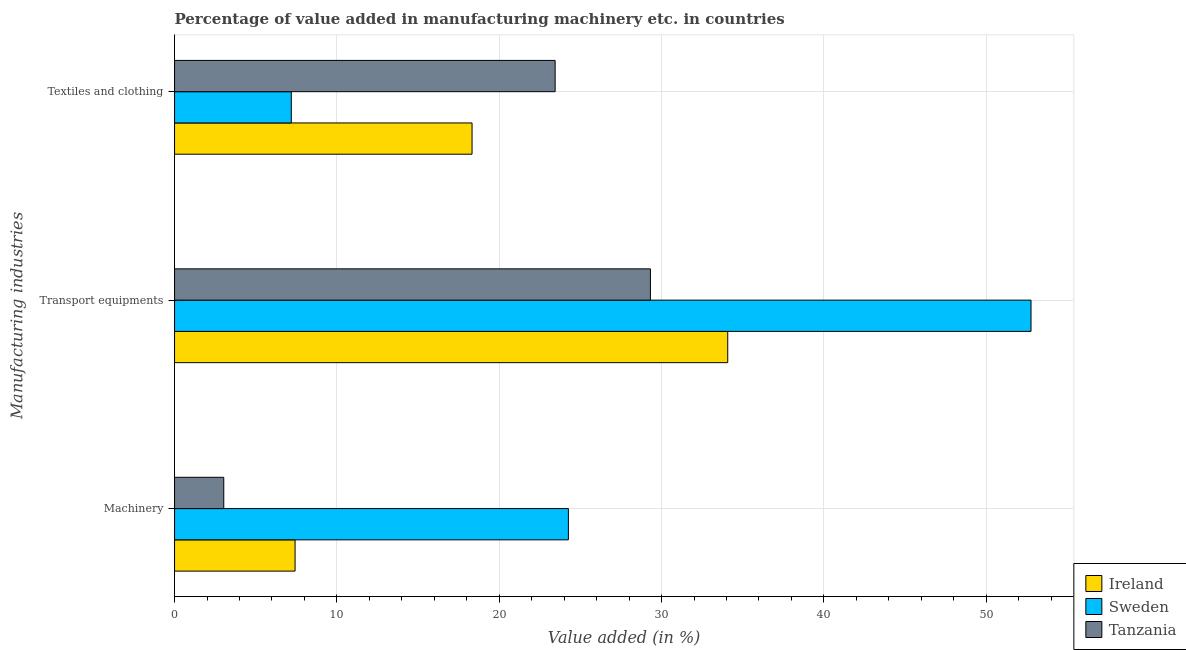How many groups of bars are there?
Provide a succinct answer. 3. Are the number of bars on each tick of the Y-axis equal?
Your answer should be compact. Yes. How many bars are there on the 3rd tick from the top?
Keep it short and to the point. 3. How many bars are there on the 3rd tick from the bottom?
Your answer should be very brief. 3. What is the label of the 2nd group of bars from the top?
Give a very brief answer. Transport equipments. What is the value added in manufacturing textile and clothing in Tanzania?
Make the answer very short. 23.45. Across all countries, what is the maximum value added in manufacturing textile and clothing?
Your answer should be very brief. 23.45. Across all countries, what is the minimum value added in manufacturing machinery?
Ensure brevity in your answer.  3.03. In which country was the value added in manufacturing machinery maximum?
Provide a short and direct response. Sweden. What is the total value added in manufacturing machinery in the graph?
Ensure brevity in your answer.  34.72. What is the difference between the value added in manufacturing textile and clothing in Ireland and that in Tanzania?
Your answer should be compact. -5.12. What is the difference between the value added in manufacturing transport equipments in Tanzania and the value added in manufacturing machinery in Sweden?
Offer a very short reply. 5.05. What is the average value added in manufacturing textile and clothing per country?
Your response must be concise. 16.32. What is the difference between the value added in manufacturing textile and clothing and value added in manufacturing machinery in Sweden?
Give a very brief answer. -17.07. What is the ratio of the value added in manufacturing transport equipments in Sweden to that in Ireland?
Your response must be concise. 1.55. Is the difference between the value added in manufacturing machinery in Tanzania and Ireland greater than the difference between the value added in manufacturing transport equipments in Tanzania and Ireland?
Provide a succinct answer. Yes. What is the difference between the highest and the second highest value added in manufacturing transport equipments?
Ensure brevity in your answer.  18.68. What is the difference between the highest and the lowest value added in manufacturing machinery?
Your answer should be compact. 21.23. In how many countries, is the value added in manufacturing machinery greater than the average value added in manufacturing machinery taken over all countries?
Your response must be concise. 1. What does the 2nd bar from the top in Transport equipments represents?
Provide a short and direct response. Sweden. What does the 3rd bar from the bottom in Transport equipments represents?
Your answer should be compact. Tanzania. How many bars are there?
Offer a very short reply. 9. How many countries are there in the graph?
Make the answer very short. 3. Does the graph contain any zero values?
Your answer should be very brief. No. Does the graph contain grids?
Provide a short and direct response. Yes. How many legend labels are there?
Provide a succinct answer. 3. What is the title of the graph?
Your answer should be very brief. Percentage of value added in manufacturing machinery etc. in countries. Does "Madagascar" appear as one of the legend labels in the graph?
Offer a terse response. No. What is the label or title of the X-axis?
Your answer should be very brief. Value added (in %). What is the label or title of the Y-axis?
Your response must be concise. Manufacturing industries. What is the Value added (in %) in Ireland in Machinery?
Ensure brevity in your answer.  7.42. What is the Value added (in %) in Sweden in Machinery?
Your answer should be compact. 24.26. What is the Value added (in %) of Tanzania in Machinery?
Provide a succinct answer. 3.03. What is the Value added (in %) of Ireland in Transport equipments?
Make the answer very short. 34.08. What is the Value added (in %) of Sweden in Transport equipments?
Give a very brief answer. 52.76. What is the Value added (in %) of Tanzania in Transport equipments?
Provide a succinct answer. 29.31. What is the Value added (in %) in Ireland in Textiles and clothing?
Keep it short and to the point. 18.33. What is the Value added (in %) in Sweden in Textiles and clothing?
Offer a terse response. 7.19. What is the Value added (in %) of Tanzania in Textiles and clothing?
Offer a very short reply. 23.45. Across all Manufacturing industries, what is the maximum Value added (in %) of Ireland?
Give a very brief answer. 34.08. Across all Manufacturing industries, what is the maximum Value added (in %) in Sweden?
Offer a very short reply. 52.76. Across all Manufacturing industries, what is the maximum Value added (in %) in Tanzania?
Keep it short and to the point. 29.31. Across all Manufacturing industries, what is the minimum Value added (in %) in Ireland?
Keep it short and to the point. 7.42. Across all Manufacturing industries, what is the minimum Value added (in %) of Sweden?
Make the answer very short. 7.19. Across all Manufacturing industries, what is the minimum Value added (in %) in Tanzania?
Ensure brevity in your answer.  3.03. What is the total Value added (in %) of Ireland in the graph?
Keep it short and to the point. 59.83. What is the total Value added (in %) of Sweden in the graph?
Your answer should be very brief. 84.21. What is the total Value added (in %) in Tanzania in the graph?
Offer a very short reply. 55.79. What is the difference between the Value added (in %) in Ireland in Machinery and that in Transport equipments?
Your answer should be compact. -26.65. What is the difference between the Value added (in %) in Sweden in Machinery and that in Transport equipments?
Make the answer very short. -28.5. What is the difference between the Value added (in %) of Tanzania in Machinery and that in Transport equipments?
Provide a succinct answer. -26.28. What is the difference between the Value added (in %) of Ireland in Machinery and that in Textiles and clothing?
Provide a short and direct response. -10.9. What is the difference between the Value added (in %) in Sweden in Machinery and that in Textiles and clothing?
Ensure brevity in your answer.  17.07. What is the difference between the Value added (in %) of Tanzania in Machinery and that in Textiles and clothing?
Offer a very short reply. -20.41. What is the difference between the Value added (in %) of Ireland in Transport equipments and that in Textiles and clothing?
Provide a short and direct response. 15.75. What is the difference between the Value added (in %) of Sweden in Transport equipments and that in Textiles and clothing?
Your answer should be very brief. 45.57. What is the difference between the Value added (in %) of Tanzania in Transport equipments and that in Textiles and clothing?
Your response must be concise. 5.87. What is the difference between the Value added (in %) in Ireland in Machinery and the Value added (in %) in Sweden in Transport equipments?
Make the answer very short. -45.34. What is the difference between the Value added (in %) of Ireland in Machinery and the Value added (in %) of Tanzania in Transport equipments?
Offer a terse response. -21.89. What is the difference between the Value added (in %) of Sweden in Machinery and the Value added (in %) of Tanzania in Transport equipments?
Offer a terse response. -5.05. What is the difference between the Value added (in %) in Ireland in Machinery and the Value added (in %) in Sweden in Textiles and clothing?
Ensure brevity in your answer.  0.23. What is the difference between the Value added (in %) of Ireland in Machinery and the Value added (in %) of Tanzania in Textiles and clothing?
Make the answer very short. -16.02. What is the difference between the Value added (in %) in Sweden in Machinery and the Value added (in %) in Tanzania in Textiles and clothing?
Your answer should be very brief. 0.82. What is the difference between the Value added (in %) of Ireland in Transport equipments and the Value added (in %) of Sweden in Textiles and clothing?
Your response must be concise. 26.89. What is the difference between the Value added (in %) in Ireland in Transport equipments and the Value added (in %) in Tanzania in Textiles and clothing?
Give a very brief answer. 10.63. What is the difference between the Value added (in %) in Sweden in Transport equipments and the Value added (in %) in Tanzania in Textiles and clothing?
Your response must be concise. 29.32. What is the average Value added (in %) of Ireland per Manufacturing industries?
Make the answer very short. 19.94. What is the average Value added (in %) of Sweden per Manufacturing industries?
Offer a very short reply. 28.07. What is the average Value added (in %) of Tanzania per Manufacturing industries?
Keep it short and to the point. 18.6. What is the difference between the Value added (in %) in Ireland and Value added (in %) in Sweden in Machinery?
Keep it short and to the point. -16.84. What is the difference between the Value added (in %) of Ireland and Value added (in %) of Tanzania in Machinery?
Ensure brevity in your answer.  4.39. What is the difference between the Value added (in %) of Sweden and Value added (in %) of Tanzania in Machinery?
Provide a succinct answer. 21.23. What is the difference between the Value added (in %) in Ireland and Value added (in %) in Sweden in Transport equipments?
Ensure brevity in your answer.  -18.68. What is the difference between the Value added (in %) in Ireland and Value added (in %) in Tanzania in Transport equipments?
Offer a terse response. 4.76. What is the difference between the Value added (in %) in Sweden and Value added (in %) in Tanzania in Transport equipments?
Offer a very short reply. 23.45. What is the difference between the Value added (in %) of Ireland and Value added (in %) of Sweden in Textiles and clothing?
Ensure brevity in your answer.  11.13. What is the difference between the Value added (in %) in Ireland and Value added (in %) in Tanzania in Textiles and clothing?
Offer a very short reply. -5.12. What is the difference between the Value added (in %) of Sweden and Value added (in %) of Tanzania in Textiles and clothing?
Your answer should be compact. -16.25. What is the ratio of the Value added (in %) of Ireland in Machinery to that in Transport equipments?
Your answer should be compact. 0.22. What is the ratio of the Value added (in %) in Sweden in Machinery to that in Transport equipments?
Keep it short and to the point. 0.46. What is the ratio of the Value added (in %) of Tanzania in Machinery to that in Transport equipments?
Keep it short and to the point. 0.1. What is the ratio of the Value added (in %) of Ireland in Machinery to that in Textiles and clothing?
Provide a succinct answer. 0.41. What is the ratio of the Value added (in %) in Sweden in Machinery to that in Textiles and clothing?
Give a very brief answer. 3.37. What is the ratio of the Value added (in %) in Tanzania in Machinery to that in Textiles and clothing?
Your response must be concise. 0.13. What is the ratio of the Value added (in %) in Ireland in Transport equipments to that in Textiles and clothing?
Your response must be concise. 1.86. What is the ratio of the Value added (in %) of Sweden in Transport equipments to that in Textiles and clothing?
Offer a very short reply. 7.34. What is the ratio of the Value added (in %) of Tanzania in Transport equipments to that in Textiles and clothing?
Your answer should be very brief. 1.25. What is the difference between the highest and the second highest Value added (in %) of Ireland?
Ensure brevity in your answer.  15.75. What is the difference between the highest and the second highest Value added (in %) of Sweden?
Ensure brevity in your answer.  28.5. What is the difference between the highest and the second highest Value added (in %) of Tanzania?
Ensure brevity in your answer.  5.87. What is the difference between the highest and the lowest Value added (in %) in Ireland?
Ensure brevity in your answer.  26.65. What is the difference between the highest and the lowest Value added (in %) of Sweden?
Your response must be concise. 45.57. What is the difference between the highest and the lowest Value added (in %) of Tanzania?
Your answer should be compact. 26.28. 